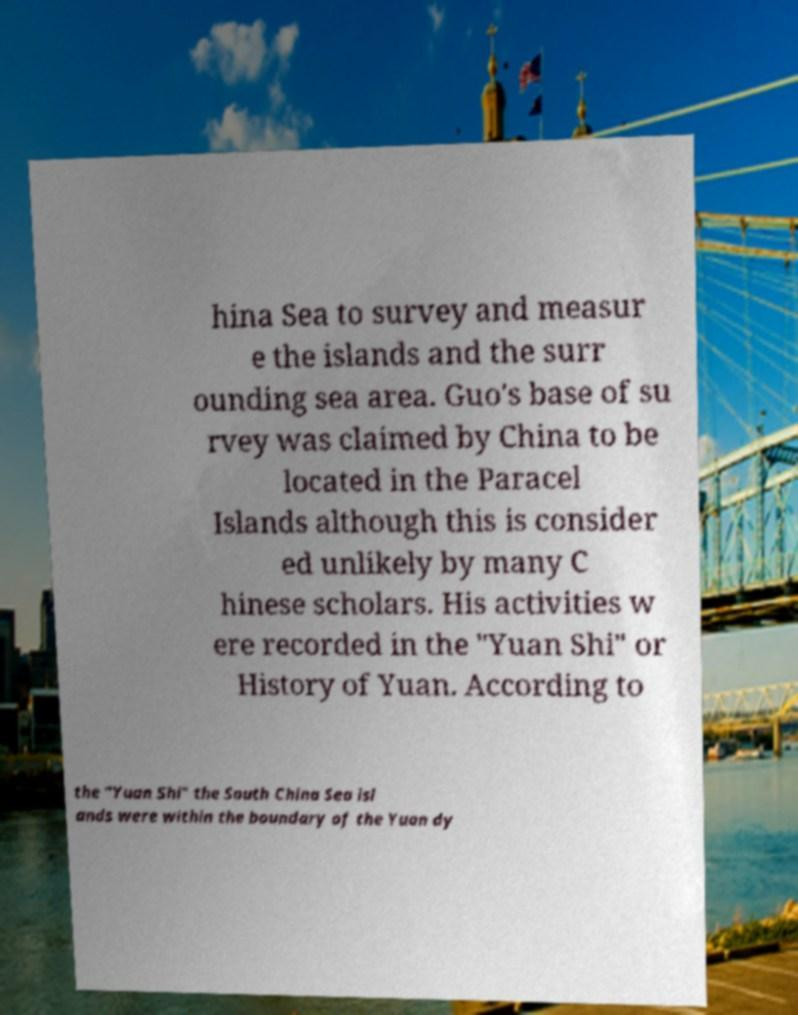There's text embedded in this image that I need extracted. Can you transcribe it verbatim? hina Sea to survey and measur e the islands and the surr ounding sea area. Guo's base of su rvey was claimed by China to be located in the Paracel Islands although this is consider ed unlikely by many C hinese scholars. His activities w ere recorded in the "Yuan Shi" or History of Yuan. According to the "Yuan Shi" the South China Sea isl ands were within the boundary of the Yuan dy 